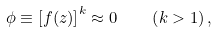Convert formula to latex. <formula><loc_0><loc_0><loc_500><loc_500>\phi \equiv \left [ f ( z ) \right ] ^ { k } \approx 0 \quad \left ( k > 1 \right ) ,</formula> 